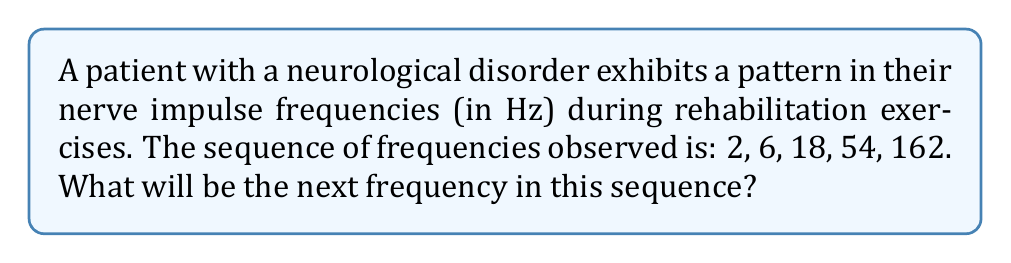What is the answer to this math problem? To solve this problem, we need to identify the pattern in the given sequence. Let's analyze the relationship between consecutive terms:

1) From 2 to 6: $6 = 2 \times 3$
2) From 6 to 18: $18 = 6 \times 3$
3) From 18 to 54: $54 = 18 \times 3$
4) From 54 to 162: $162 = 54 \times 3$

We can see that each term is multiplied by 3 to get the next term. This forms a geometric sequence with a common ratio of 3.

The general formula for a geometric sequence is:

$$a_n = a_1 \times r^{n-1}$$

Where:
$a_n$ is the nth term
$a_1$ is the first term (2 in this case)
$r$ is the common ratio (3 in this case)
$n$ is the position of the term

To find the next (6th) term, we use:

$$a_6 = 2 \times 3^{6-1} = 2 \times 3^5 = 2 \times 243 = 486$$

Therefore, the next frequency in the sequence will be 486 Hz.
Answer: 486 Hz 